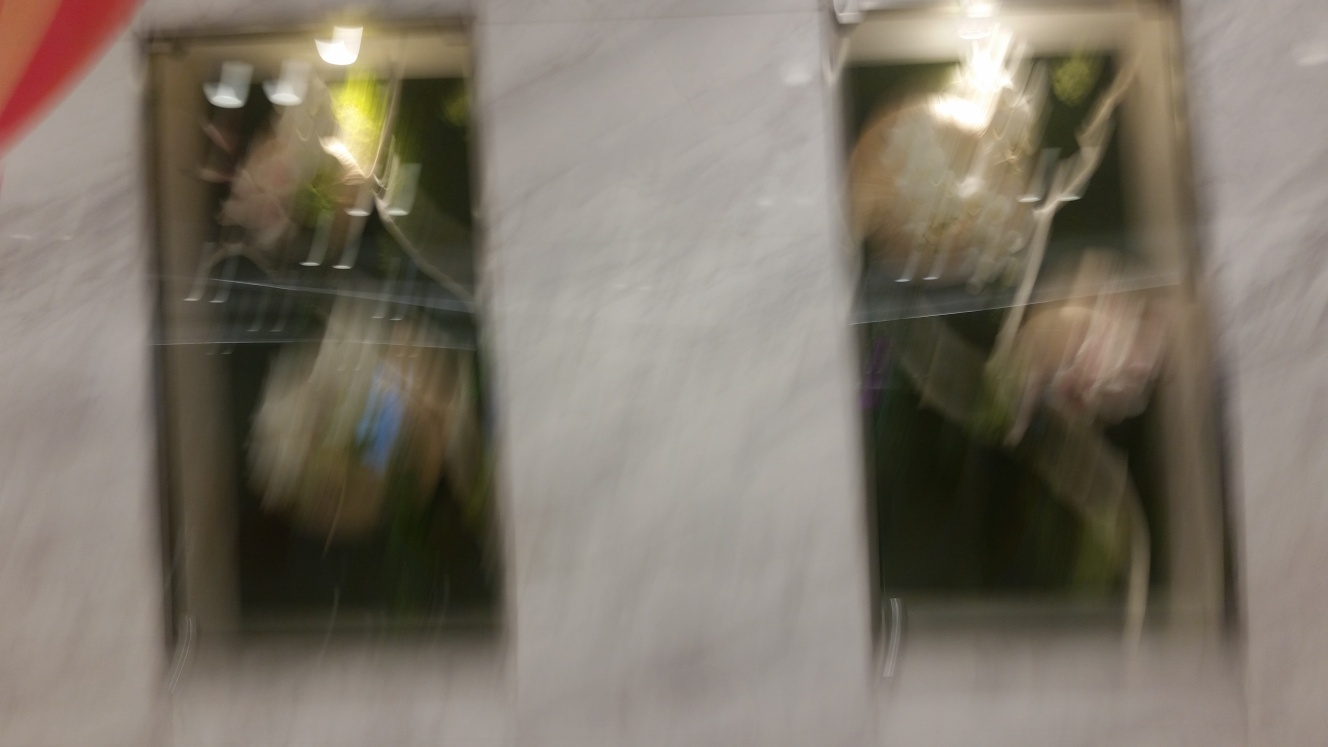Can you describe what's in the image despite the blur? Despite the motion blur, the image seems to capture an indoor scene possibly through a glass window or reflection. There are hints of metallic and glass materials, suggesting a modern setting. It's challenging to discern specific objects or people, which adds a sense of mystery to the photo. 